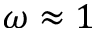<formula> <loc_0><loc_0><loc_500><loc_500>\omega \approx 1</formula> 